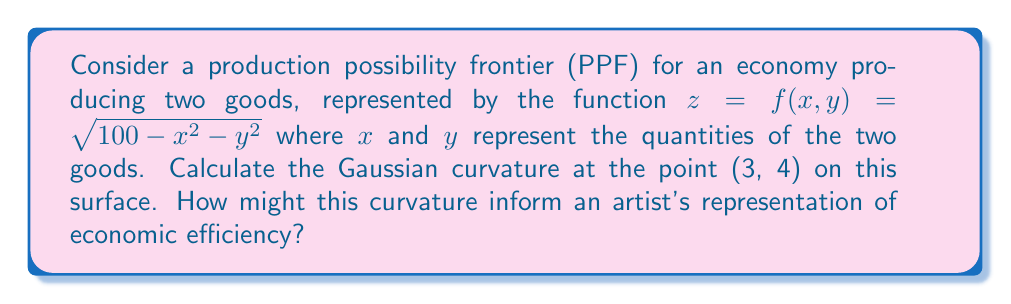Can you answer this question? To find the Gaussian curvature, we need to follow these steps:

1) First, we need to calculate the first and second partial derivatives:

   $f_x = \frac{-x}{\sqrt{100 - x^2 - y^2}}$
   $f_y = \frac{-y}{\sqrt{100 - x^2 - y^2}}$
   $f_{xx} = \frac{-\sqrt{100 - x^2 - y^2} + x^2/\sqrt{100 - x^2 - y^2}}{100 - x^2 - y^2}$
   $f_{yy} = \frac{-\sqrt{100 - x^2 - y^2} + y^2/\sqrt{100 - x^2 - y^2}}{100 - x^2 - y^2}$
   $f_{xy} = f_{yx} = \frac{xy}{(100 - x^2 - y^2)^{3/2}}$

2) The Gaussian curvature K is given by:

   $K = \frac{f_{xx}f_{yy} - f_{xy}^2}{(1 + f_x^2 + f_y^2)^2}$

3) Substituting x = 3 and y = 4:

   $f_x = -\frac{3}{\sqrt{91}} \approx -0.3145$
   $f_y = -\frac{4}{\sqrt{91}} \approx -0.4193$
   $f_{xx} = \frac{-\sqrt{91} + 9/\sqrt{91}}{91} \approx -0.1039$
   $f_{yy} = \frac{-\sqrt{91} + 16/\sqrt{91}}{91} \approx -0.0925$
   $f_{xy} = \frac{12}{91^{3/2}} \approx 0.0138$

4) Plugging these values into the Gaussian curvature formula:

   $K = \frac{(-0.1039)(-0.0925) - (0.0138)^2}{(1 + (-0.3145)^2 + (-0.4193)^2)^2} \approx 0.0098$

5) For an artist, this positive Gaussian curvature indicates that the PPF is locally shaped like an elliptic paraboloid at (3, 4). This convex shape represents increasing opportunity costs as more of either good is produced, which is a fundamental concept in economics. The magnitude of the curvature (close to 0 but positive) suggests a gradual change in the trade-off between the two goods, which could be represented in artwork through subtle gradients or gentle curves.
Answer: $K \approx 0.0098$ at (3, 4), representing a gently curved, elliptic paraboloid shape. 